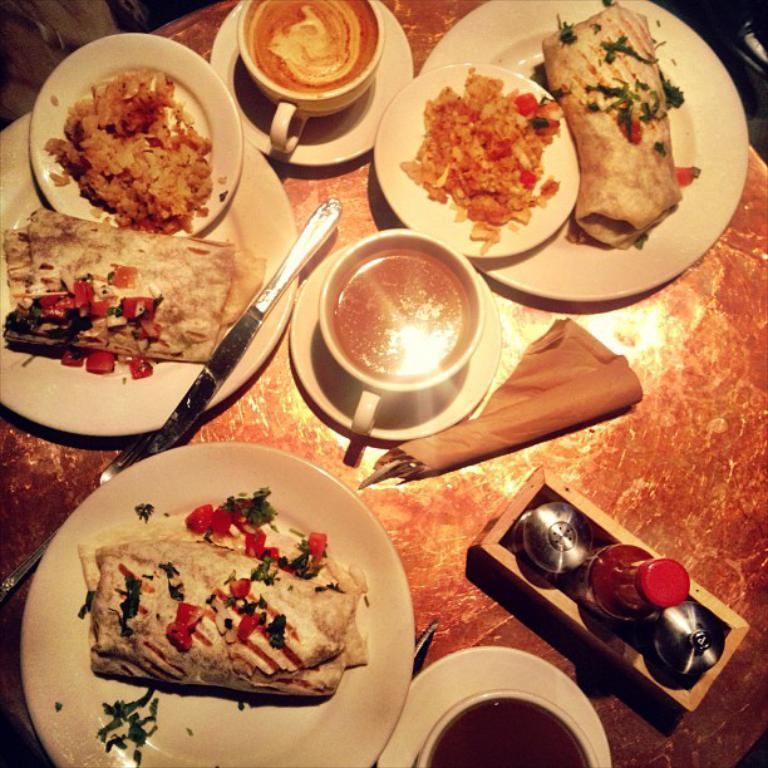What is on the plates in the image? There is food in the plates in the image. What can be seen beside the plates? There are cups beside the plates in the image. What utensil is present in the image? There is at least one knife in the image. What else is on the table in the image? There are bottles on the table in the image. How does the crowd interact with the food in the image? There is no crowd present in the image; it only shows plates with food, cups, a knife, and bottles on the table. 